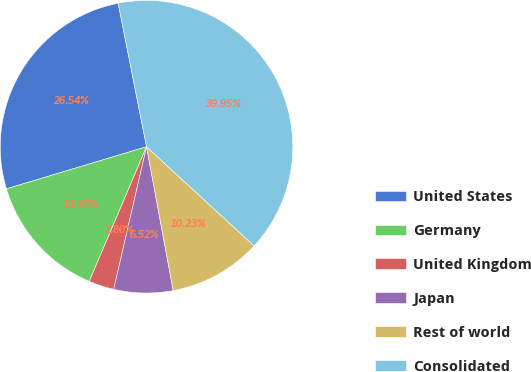Convert chart to OTSL. <chart><loc_0><loc_0><loc_500><loc_500><pie_chart><fcel>United States<fcel>Germany<fcel>United Kingdom<fcel>Japan<fcel>Rest of world<fcel>Consolidated<nl><fcel>26.54%<fcel>13.95%<fcel>2.8%<fcel>6.52%<fcel>10.23%<fcel>39.95%<nl></chart> 